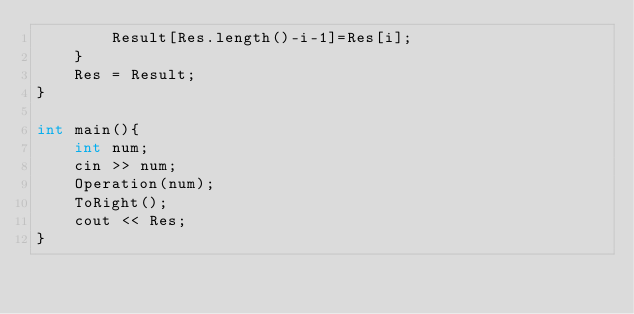Convert code to text. <code><loc_0><loc_0><loc_500><loc_500><_C++_>        Result[Res.length()-i-1]=Res[i];
    }
    Res = Result;
}

int main(){
    int num;
    cin >> num;
    Operation(num);
    ToRight();
    cout << Res;
}</code> 